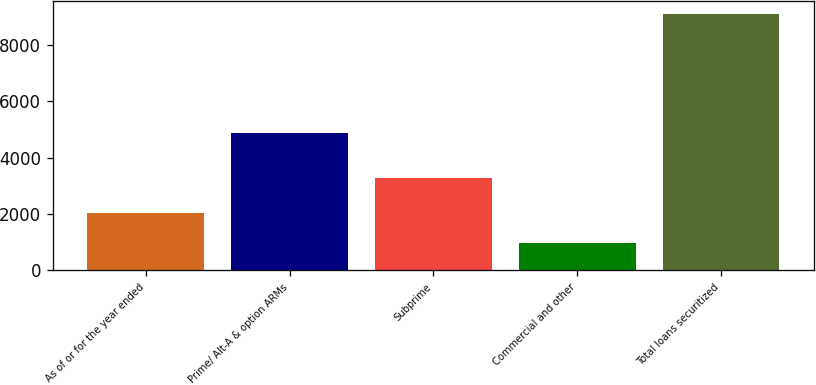<chart> <loc_0><loc_0><loc_500><loc_500><bar_chart><fcel>As of or for the year ended<fcel>Prime/ Alt-A & option ARMs<fcel>Subprime<fcel>Commercial and other<fcel>Total loans securitized<nl><fcel>2017<fcel>4870<fcel>3276<fcel>957<fcel>9103<nl></chart> 